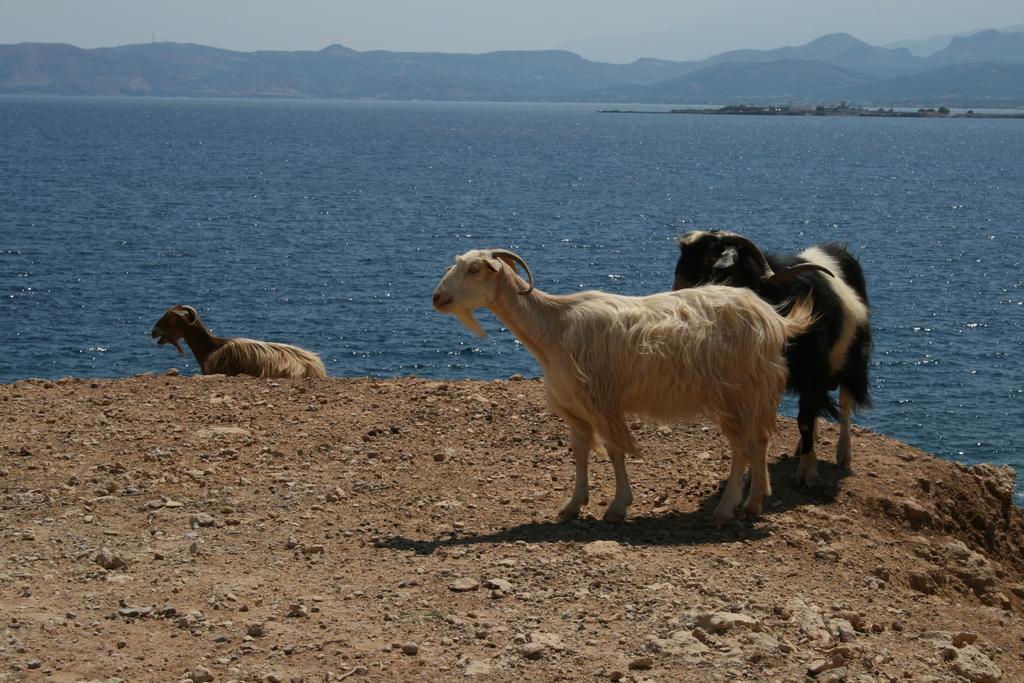Could you give a brief overview of what you see in this image? In this image, we can see some animals on the ground, we can see water, there are some mountains, at the top there is a sky. 